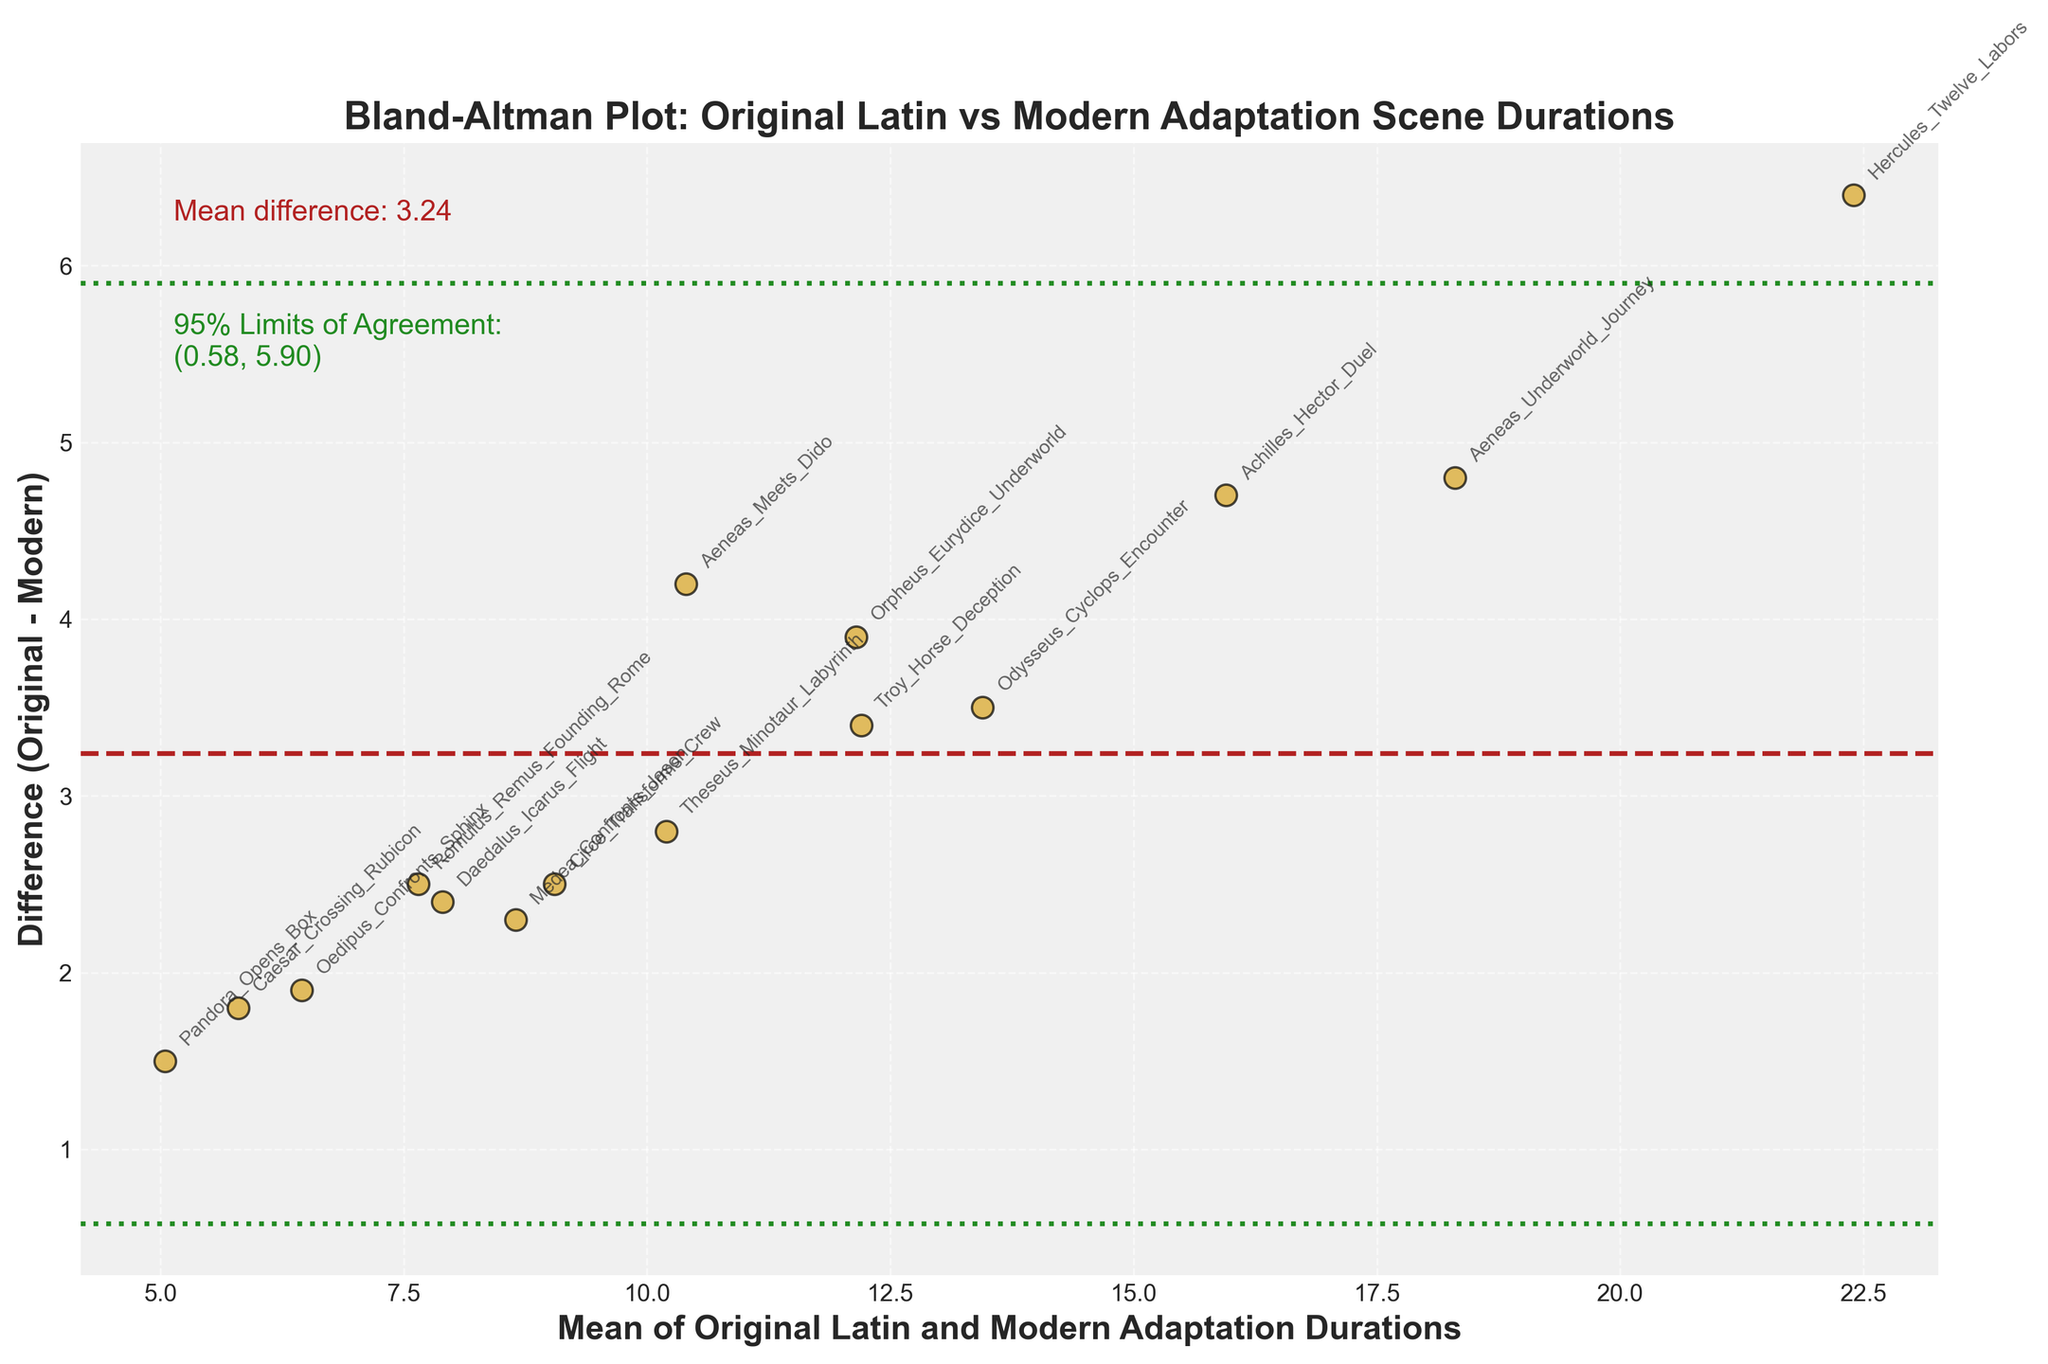What's the title of the figure? The title of the figure is displayed prominently at the top, indicating the main focus of the plot.
Answer: Bland-Altman Plot: Original Latin vs Modern Adaptation Scene Durations How many scenes are compared in the figure? To find the number of scenes compared, count the number of individual data points present in the scatter plot.
Answer: 15 What does the horizontal dashed line represent? The horizontal dashed line represents the mean difference between the durations of scenes in original Latin texts and modern adaptations. This line is typically used to visualize the average discrepancy.
Answer: Mean difference Which scene has the largest difference in duration between original Latin and modern adaptations? To find this, we need to identify the data point with the greatest vertical distance from the horizontal axis representing the difference. This means comparing the largest positive or negative difference.
Answer: Hercules Twelve Labors What are the 95% Limits of Agreement? The 95% Limits of Agreement are represented by the two dotted horizontal lines. One should look at the annotations near these lines that display the range.
Answer: (-1.86, 7.02) Are there scenes where the duration in the modern adaptation is longer than the original Latin duration? For such scenes, the difference (original - modern) would be negative, so we should look for data points below the zero line on the y-axis.
Answer: No What's the range of mean durations on the x-axis? To determine this, observe the smallest and largest values on the x-axis. These represent the mean durations of scenes in both original Latin texts and modern adaptations.
Answer: (5, 22) Which scene has the smallest mean duration of the two versions? Identify the point closest to the y-axis where the mean duration would be the smallest based on the x-axis values.
Answer: Pandora Opens Box What is the mean of the mean differences shown by the horizontal dashed line? The horizontal dashed line positions the mean difference visually on the plot, usually indicated by an annotation.
Answer: 2.58 Is there any trend indicating that longer scenes in original Latin texts tend to have larger differences with modern adaptations? Determine if data points are consistently farther from the zero line as the mean duration increases along the x-axis, suggesting a trend.
Answer: No clear trend 